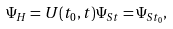Convert formula to latex. <formula><loc_0><loc_0><loc_500><loc_500>\Psi _ { H } = U ( t _ { 0 } , t ) \Psi _ { S t } = \Psi _ { S t _ { 0 } } ,</formula> 